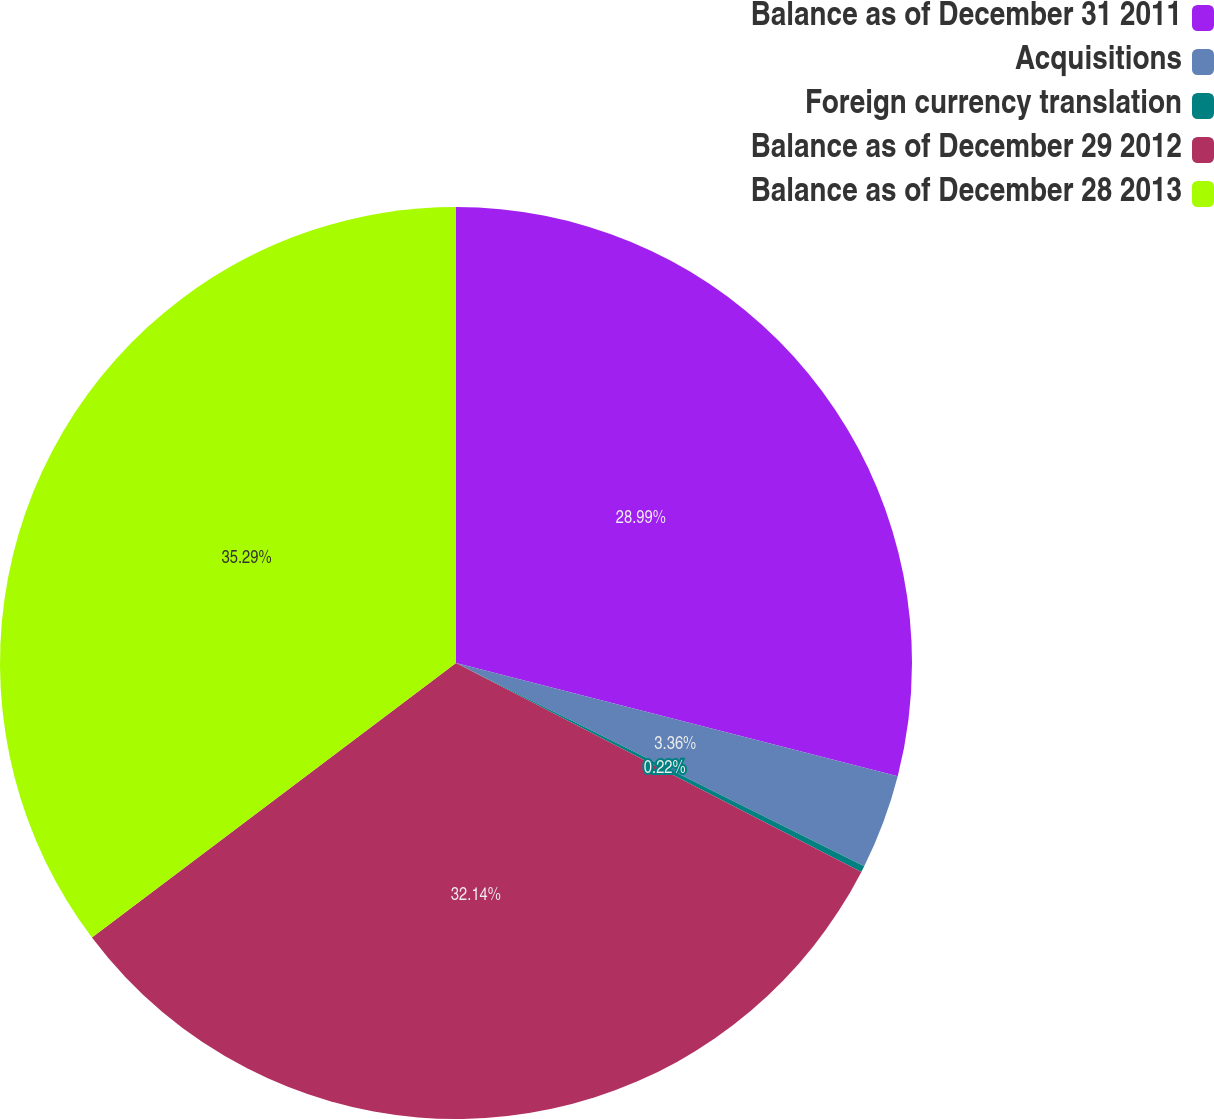Convert chart. <chart><loc_0><loc_0><loc_500><loc_500><pie_chart><fcel>Balance as of December 31 2011<fcel>Acquisitions<fcel>Foreign currency translation<fcel>Balance as of December 29 2012<fcel>Balance as of December 28 2013<nl><fcel>28.99%<fcel>3.36%<fcel>0.22%<fcel>32.14%<fcel>35.28%<nl></chart> 